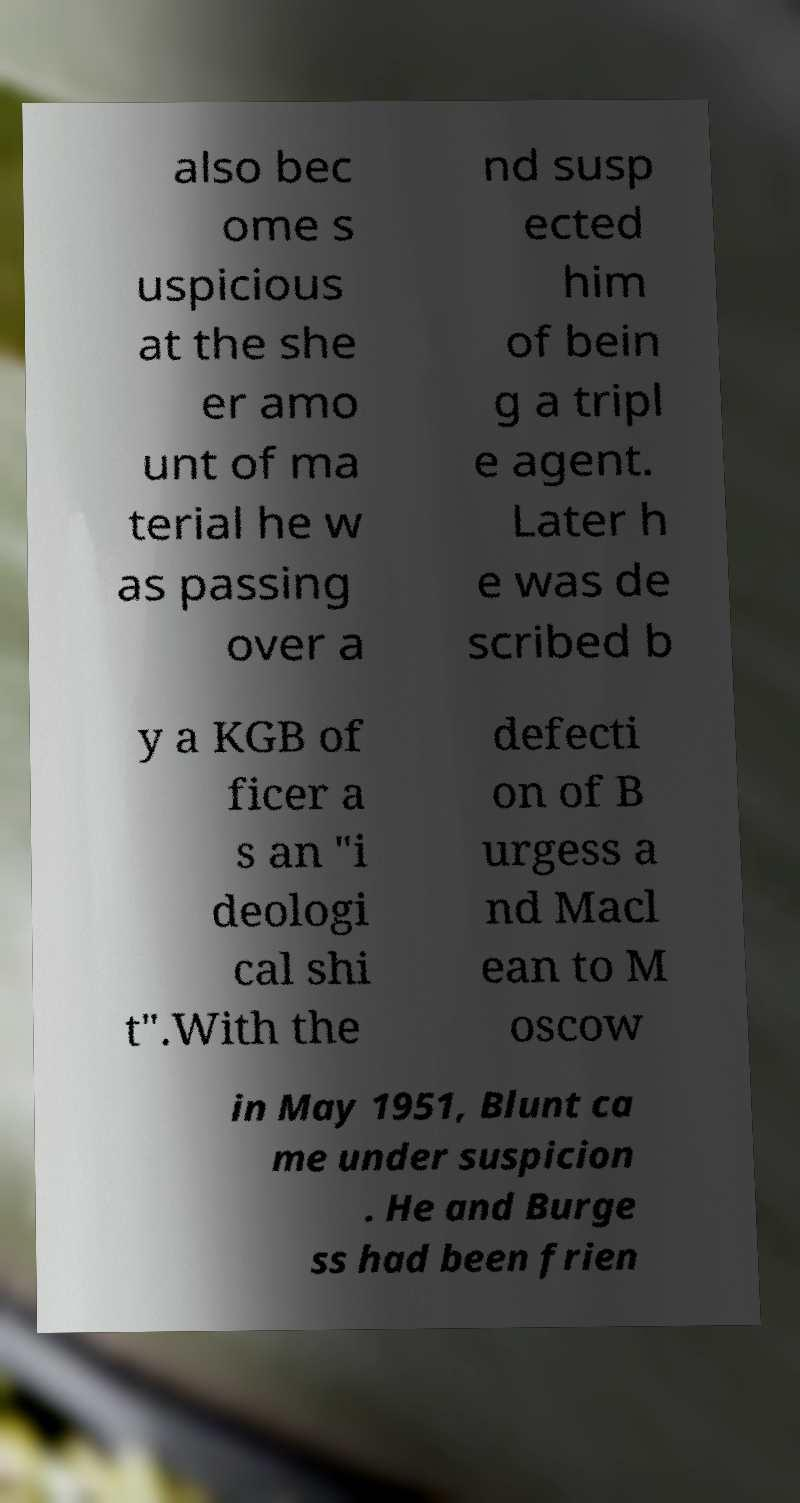I need the written content from this picture converted into text. Can you do that? also bec ome s uspicious at the she er amo unt of ma terial he w as passing over a nd susp ected him of bein g a tripl e agent. Later h e was de scribed b y a KGB of ficer a s an "i deologi cal shi t".With the defecti on of B urgess a nd Macl ean to M oscow in May 1951, Blunt ca me under suspicion . He and Burge ss had been frien 